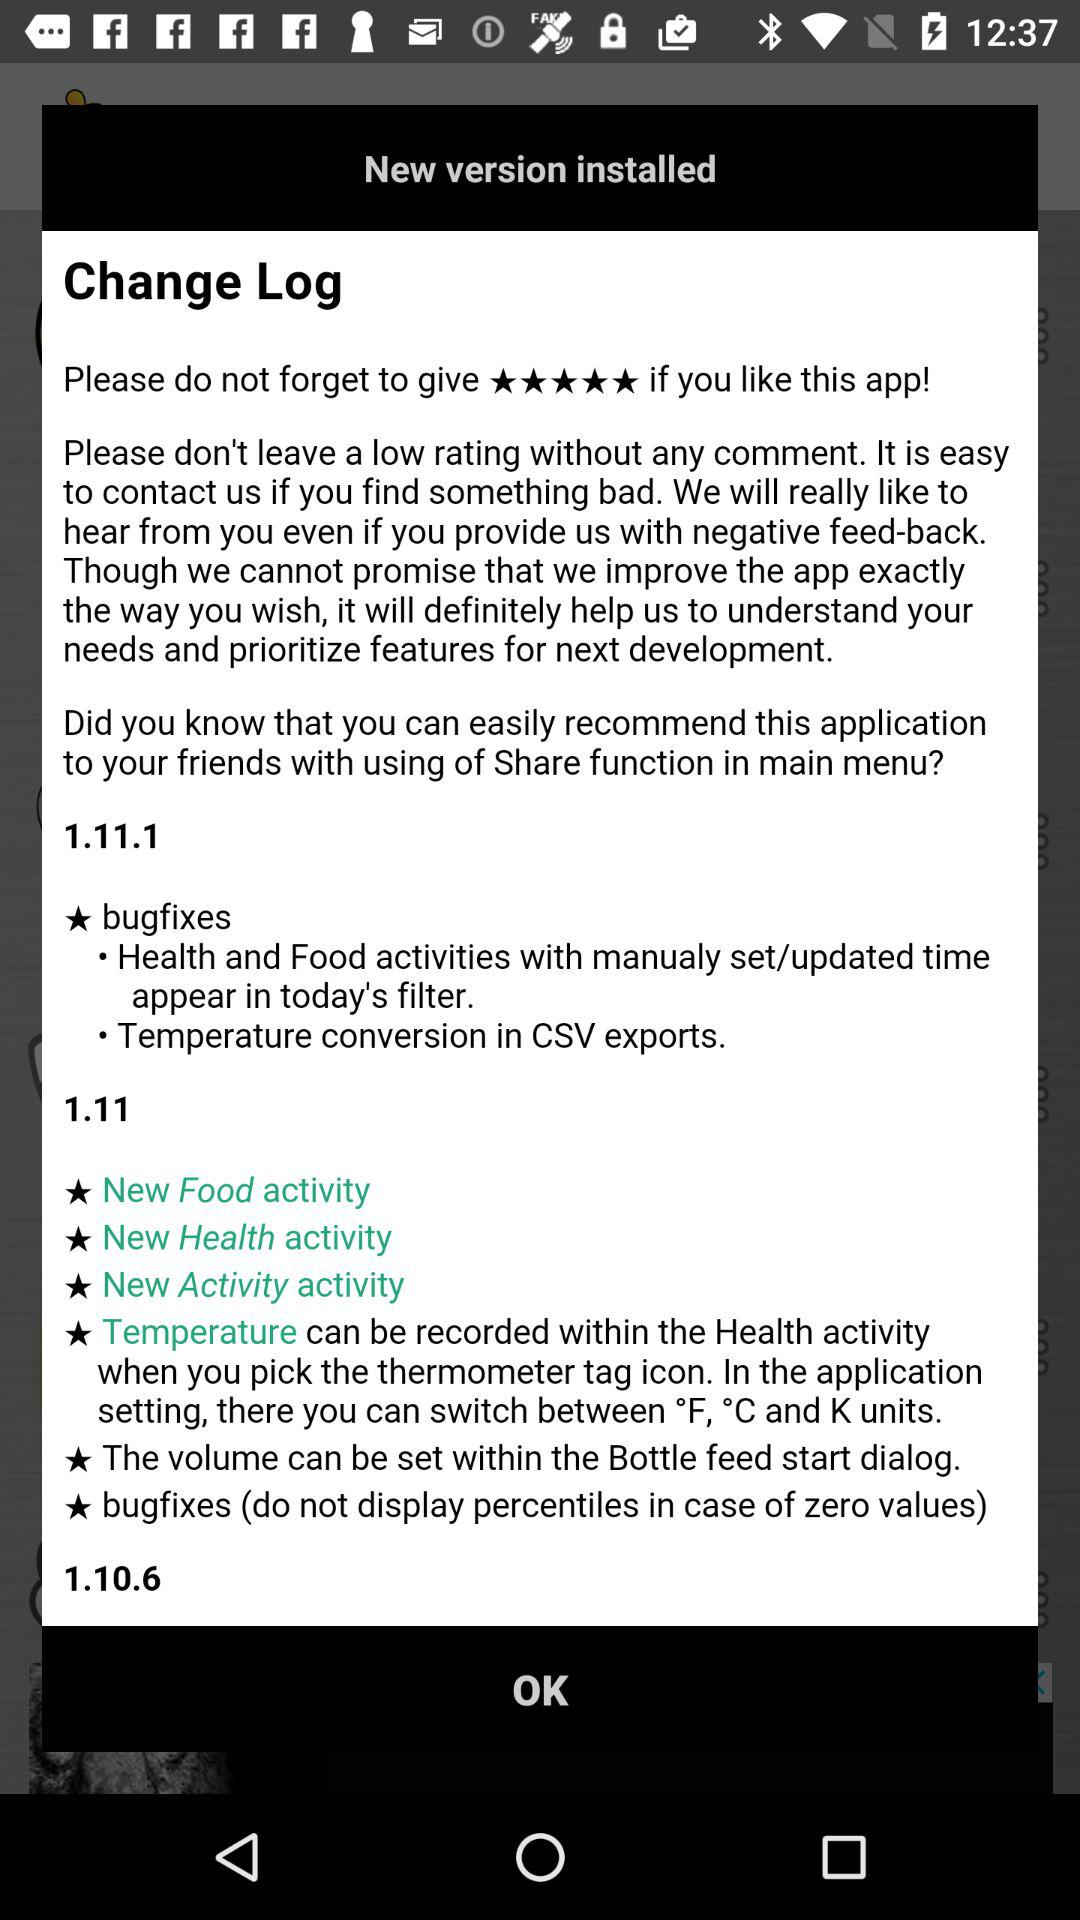How many new activities were added in version 1.11?
Answer the question using a single word or phrase. 3 